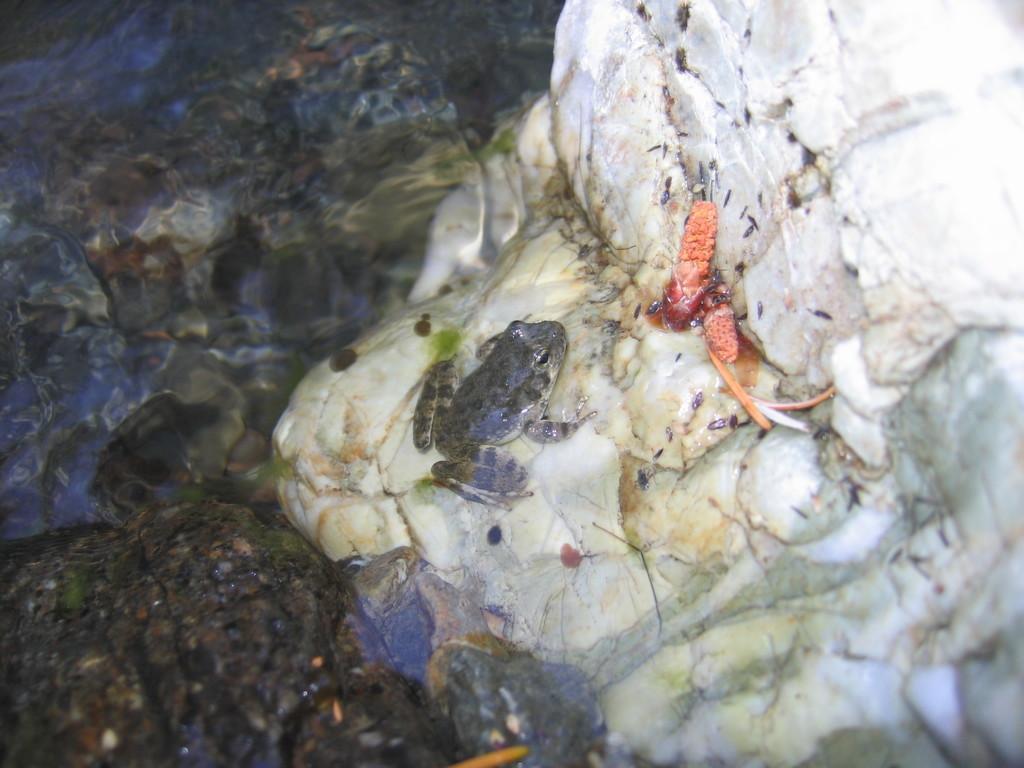Please provide a concise description of this image. In this image I can see the frog which is in white and grey color. It is on the rock. To the left I can see the black color rock but it is blurry. 